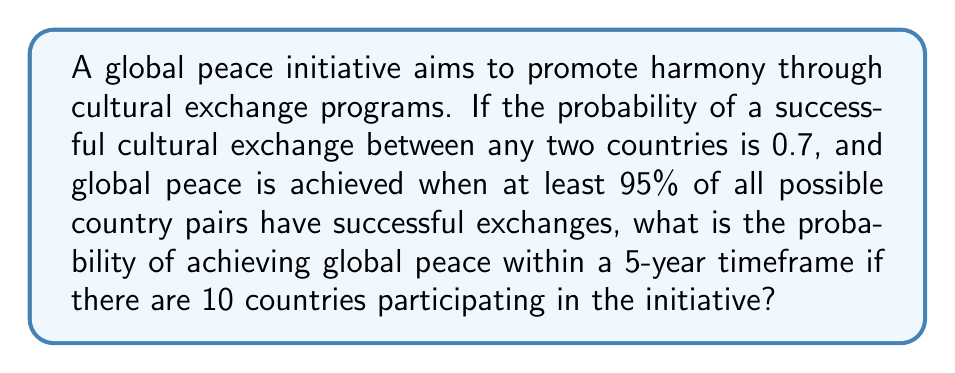Can you answer this question? Let's approach this step-by-step:

1) First, we need to calculate the total number of possible country pairs:
   $$\binom{10}{2} = \frac{10!}{2!(10-2)!} = 45$$ pairs

2) For global peace, we need at least 95% of these pairs to have successful exchanges:
   $$45 \times 0.95 = 42.75$$
   Rounding up, we need at least 43 successful exchanges.

3) This scenario follows a binomial distribution with parameters:
   $n = 45$ (total number of trials)
   $p = 0.7$ (probability of success for each trial)
   $k \geq 43$ (number of successes needed)

4) The probability of achieving global peace is the sum of probabilities for 43, 44, and 45 successes:

   $$P(\text{Global Peace}) = P(X \geq 43) = P(X = 43) + P(X = 44) + P(X = 45)$$

5) Using the binomial probability formula:
   $$P(X = k) = \binom{n}{k} p^k (1-p)^{n-k}$$

6) Calculating each term:
   $$P(43) = \binom{45}{43} 0.7^{43} 0.3^2 = 0.2603$$
   $$P(44) = \binom{45}{44} 0.7^{44} 0.3^1 = 0.3020$$
   $$P(45) = \binom{45}{45} 0.7^{45} 0.3^0 = 0.1311$$

7) Sum these probabilities:
   $$P(\text{Global Peace}) = 0.2603 + 0.3020 + 0.1311 = 0.6934$$
Answer: 0.6934 